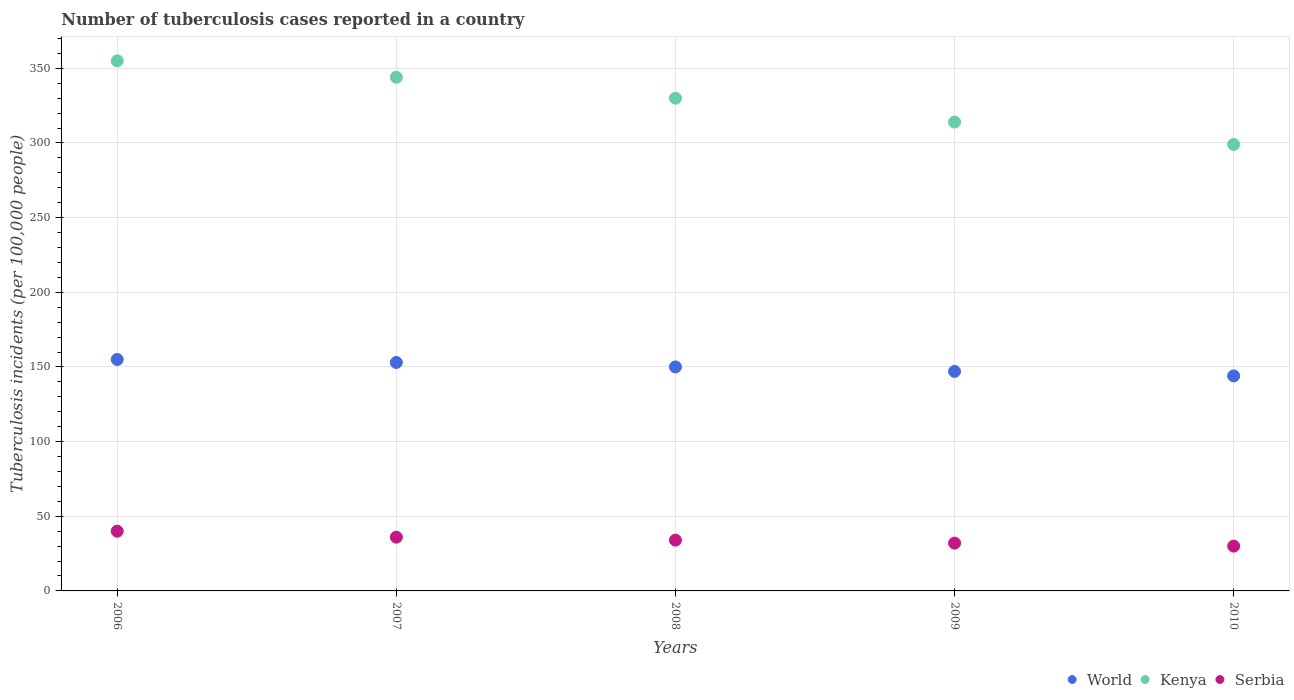How many different coloured dotlines are there?
Make the answer very short. 3. Is the number of dotlines equal to the number of legend labels?
Ensure brevity in your answer.  Yes. What is the number of tuberculosis cases reported in in World in 2008?
Your response must be concise. 150. Across all years, what is the maximum number of tuberculosis cases reported in in Serbia?
Offer a terse response. 40. Across all years, what is the minimum number of tuberculosis cases reported in in Serbia?
Your response must be concise. 30. In which year was the number of tuberculosis cases reported in in Kenya maximum?
Give a very brief answer. 2006. What is the total number of tuberculosis cases reported in in World in the graph?
Provide a short and direct response. 749. What is the difference between the number of tuberculosis cases reported in in Kenya in 2006 and that in 2007?
Provide a succinct answer. 11. What is the difference between the number of tuberculosis cases reported in in Kenya in 2010 and the number of tuberculosis cases reported in in Serbia in 2009?
Offer a terse response. 267. What is the average number of tuberculosis cases reported in in Kenya per year?
Provide a succinct answer. 328.4. In the year 2007, what is the difference between the number of tuberculosis cases reported in in Serbia and number of tuberculosis cases reported in in World?
Ensure brevity in your answer.  -117. What is the ratio of the number of tuberculosis cases reported in in World in 2008 to that in 2009?
Offer a very short reply. 1.02. Is the difference between the number of tuberculosis cases reported in in Serbia in 2006 and 2009 greater than the difference between the number of tuberculosis cases reported in in World in 2006 and 2009?
Offer a very short reply. No. What is the difference between the highest and the lowest number of tuberculosis cases reported in in World?
Keep it short and to the point. 11. How many dotlines are there?
Make the answer very short. 3. How many years are there in the graph?
Your answer should be compact. 5. Are the values on the major ticks of Y-axis written in scientific E-notation?
Ensure brevity in your answer.  No. Does the graph contain any zero values?
Keep it short and to the point. No. Does the graph contain grids?
Ensure brevity in your answer.  Yes. Where does the legend appear in the graph?
Provide a succinct answer. Bottom right. How many legend labels are there?
Ensure brevity in your answer.  3. How are the legend labels stacked?
Offer a very short reply. Horizontal. What is the title of the graph?
Your answer should be compact. Number of tuberculosis cases reported in a country. What is the label or title of the X-axis?
Offer a very short reply. Years. What is the label or title of the Y-axis?
Your answer should be very brief. Tuberculosis incidents (per 100,0 people). What is the Tuberculosis incidents (per 100,000 people) of World in 2006?
Keep it short and to the point. 155. What is the Tuberculosis incidents (per 100,000 people) of Kenya in 2006?
Offer a terse response. 355. What is the Tuberculosis incidents (per 100,000 people) of Serbia in 2006?
Provide a succinct answer. 40. What is the Tuberculosis incidents (per 100,000 people) in World in 2007?
Offer a terse response. 153. What is the Tuberculosis incidents (per 100,000 people) in Kenya in 2007?
Provide a short and direct response. 344. What is the Tuberculosis incidents (per 100,000 people) of World in 2008?
Your answer should be compact. 150. What is the Tuberculosis incidents (per 100,000 people) in Kenya in 2008?
Your response must be concise. 330. What is the Tuberculosis incidents (per 100,000 people) in Serbia in 2008?
Offer a very short reply. 34. What is the Tuberculosis incidents (per 100,000 people) of World in 2009?
Make the answer very short. 147. What is the Tuberculosis incidents (per 100,000 people) in Kenya in 2009?
Your answer should be compact. 314. What is the Tuberculosis incidents (per 100,000 people) in Serbia in 2009?
Provide a succinct answer. 32. What is the Tuberculosis incidents (per 100,000 people) in World in 2010?
Your response must be concise. 144. What is the Tuberculosis incidents (per 100,000 people) in Kenya in 2010?
Ensure brevity in your answer.  299. What is the Tuberculosis incidents (per 100,000 people) in Serbia in 2010?
Give a very brief answer. 30. Across all years, what is the maximum Tuberculosis incidents (per 100,000 people) of World?
Offer a terse response. 155. Across all years, what is the maximum Tuberculosis incidents (per 100,000 people) of Kenya?
Your answer should be very brief. 355. Across all years, what is the minimum Tuberculosis incidents (per 100,000 people) of World?
Keep it short and to the point. 144. Across all years, what is the minimum Tuberculosis incidents (per 100,000 people) in Kenya?
Your answer should be very brief. 299. What is the total Tuberculosis incidents (per 100,000 people) of World in the graph?
Your response must be concise. 749. What is the total Tuberculosis incidents (per 100,000 people) of Kenya in the graph?
Give a very brief answer. 1642. What is the total Tuberculosis incidents (per 100,000 people) of Serbia in the graph?
Offer a very short reply. 172. What is the difference between the Tuberculosis incidents (per 100,000 people) of Serbia in 2006 and that in 2007?
Make the answer very short. 4. What is the difference between the Tuberculosis incidents (per 100,000 people) in World in 2006 and that in 2008?
Give a very brief answer. 5. What is the difference between the Tuberculosis incidents (per 100,000 people) in Serbia in 2006 and that in 2008?
Provide a short and direct response. 6. What is the difference between the Tuberculosis incidents (per 100,000 people) in World in 2006 and that in 2009?
Ensure brevity in your answer.  8. What is the difference between the Tuberculosis incidents (per 100,000 people) of Serbia in 2006 and that in 2009?
Your answer should be very brief. 8. What is the difference between the Tuberculosis incidents (per 100,000 people) in Kenya in 2006 and that in 2010?
Ensure brevity in your answer.  56. What is the difference between the Tuberculosis incidents (per 100,000 people) in Serbia in 2006 and that in 2010?
Give a very brief answer. 10. What is the difference between the Tuberculosis incidents (per 100,000 people) in Serbia in 2007 and that in 2008?
Offer a very short reply. 2. What is the difference between the Tuberculosis incidents (per 100,000 people) in World in 2007 and that in 2009?
Your answer should be compact. 6. What is the difference between the Tuberculosis incidents (per 100,000 people) of Serbia in 2007 and that in 2009?
Give a very brief answer. 4. What is the difference between the Tuberculosis incidents (per 100,000 people) in Kenya in 2007 and that in 2010?
Your response must be concise. 45. What is the difference between the Tuberculosis incidents (per 100,000 people) of Kenya in 2008 and that in 2010?
Your answer should be compact. 31. What is the difference between the Tuberculosis incidents (per 100,000 people) in Serbia in 2008 and that in 2010?
Provide a succinct answer. 4. What is the difference between the Tuberculosis incidents (per 100,000 people) of World in 2009 and that in 2010?
Give a very brief answer. 3. What is the difference between the Tuberculosis incidents (per 100,000 people) in Kenya in 2009 and that in 2010?
Ensure brevity in your answer.  15. What is the difference between the Tuberculosis incidents (per 100,000 people) in World in 2006 and the Tuberculosis incidents (per 100,000 people) in Kenya in 2007?
Give a very brief answer. -189. What is the difference between the Tuberculosis incidents (per 100,000 people) in World in 2006 and the Tuberculosis incidents (per 100,000 people) in Serbia in 2007?
Your response must be concise. 119. What is the difference between the Tuberculosis incidents (per 100,000 people) of Kenya in 2006 and the Tuberculosis incidents (per 100,000 people) of Serbia in 2007?
Make the answer very short. 319. What is the difference between the Tuberculosis incidents (per 100,000 people) in World in 2006 and the Tuberculosis incidents (per 100,000 people) in Kenya in 2008?
Offer a terse response. -175. What is the difference between the Tuberculosis incidents (per 100,000 people) of World in 2006 and the Tuberculosis incidents (per 100,000 people) of Serbia in 2008?
Your answer should be compact. 121. What is the difference between the Tuberculosis incidents (per 100,000 people) of Kenya in 2006 and the Tuberculosis incidents (per 100,000 people) of Serbia in 2008?
Keep it short and to the point. 321. What is the difference between the Tuberculosis incidents (per 100,000 people) of World in 2006 and the Tuberculosis incidents (per 100,000 people) of Kenya in 2009?
Provide a short and direct response. -159. What is the difference between the Tuberculosis incidents (per 100,000 people) of World in 2006 and the Tuberculosis incidents (per 100,000 people) of Serbia in 2009?
Your answer should be compact. 123. What is the difference between the Tuberculosis incidents (per 100,000 people) in Kenya in 2006 and the Tuberculosis incidents (per 100,000 people) in Serbia in 2009?
Make the answer very short. 323. What is the difference between the Tuberculosis incidents (per 100,000 people) in World in 2006 and the Tuberculosis incidents (per 100,000 people) in Kenya in 2010?
Provide a succinct answer. -144. What is the difference between the Tuberculosis incidents (per 100,000 people) of World in 2006 and the Tuberculosis incidents (per 100,000 people) of Serbia in 2010?
Your answer should be compact. 125. What is the difference between the Tuberculosis incidents (per 100,000 people) in Kenya in 2006 and the Tuberculosis incidents (per 100,000 people) in Serbia in 2010?
Your answer should be compact. 325. What is the difference between the Tuberculosis incidents (per 100,000 people) of World in 2007 and the Tuberculosis incidents (per 100,000 people) of Kenya in 2008?
Your answer should be very brief. -177. What is the difference between the Tuberculosis incidents (per 100,000 people) of World in 2007 and the Tuberculosis incidents (per 100,000 people) of Serbia in 2008?
Your response must be concise. 119. What is the difference between the Tuberculosis incidents (per 100,000 people) of Kenya in 2007 and the Tuberculosis incidents (per 100,000 people) of Serbia in 2008?
Provide a short and direct response. 310. What is the difference between the Tuberculosis incidents (per 100,000 people) of World in 2007 and the Tuberculosis incidents (per 100,000 people) of Kenya in 2009?
Give a very brief answer. -161. What is the difference between the Tuberculosis incidents (per 100,000 people) of World in 2007 and the Tuberculosis incidents (per 100,000 people) of Serbia in 2009?
Your answer should be very brief. 121. What is the difference between the Tuberculosis incidents (per 100,000 people) in Kenya in 2007 and the Tuberculosis incidents (per 100,000 people) in Serbia in 2009?
Your answer should be compact. 312. What is the difference between the Tuberculosis incidents (per 100,000 people) of World in 2007 and the Tuberculosis incidents (per 100,000 people) of Kenya in 2010?
Provide a short and direct response. -146. What is the difference between the Tuberculosis incidents (per 100,000 people) of World in 2007 and the Tuberculosis incidents (per 100,000 people) of Serbia in 2010?
Ensure brevity in your answer.  123. What is the difference between the Tuberculosis incidents (per 100,000 people) of Kenya in 2007 and the Tuberculosis incidents (per 100,000 people) of Serbia in 2010?
Offer a very short reply. 314. What is the difference between the Tuberculosis incidents (per 100,000 people) in World in 2008 and the Tuberculosis incidents (per 100,000 people) in Kenya in 2009?
Make the answer very short. -164. What is the difference between the Tuberculosis incidents (per 100,000 people) in World in 2008 and the Tuberculosis incidents (per 100,000 people) in Serbia in 2009?
Your answer should be compact. 118. What is the difference between the Tuberculosis incidents (per 100,000 people) of Kenya in 2008 and the Tuberculosis incidents (per 100,000 people) of Serbia in 2009?
Provide a succinct answer. 298. What is the difference between the Tuberculosis incidents (per 100,000 people) in World in 2008 and the Tuberculosis incidents (per 100,000 people) in Kenya in 2010?
Provide a short and direct response. -149. What is the difference between the Tuberculosis incidents (per 100,000 people) of World in 2008 and the Tuberculosis incidents (per 100,000 people) of Serbia in 2010?
Provide a short and direct response. 120. What is the difference between the Tuberculosis incidents (per 100,000 people) of Kenya in 2008 and the Tuberculosis incidents (per 100,000 people) of Serbia in 2010?
Your answer should be very brief. 300. What is the difference between the Tuberculosis incidents (per 100,000 people) of World in 2009 and the Tuberculosis incidents (per 100,000 people) of Kenya in 2010?
Your answer should be very brief. -152. What is the difference between the Tuberculosis incidents (per 100,000 people) of World in 2009 and the Tuberculosis incidents (per 100,000 people) of Serbia in 2010?
Ensure brevity in your answer.  117. What is the difference between the Tuberculosis incidents (per 100,000 people) in Kenya in 2009 and the Tuberculosis incidents (per 100,000 people) in Serbia in 2010?
Your answer should be very brief. 284. What is the average Tuberculosis incidents (per 100,000 people) of World per year?
Offer a terse response. 149.8. What is the average Tuberculosis incidents (per 100,000 people) of Kenya per year?
Make the answer very short. 328.4. What is the average Tuberculosis incidents (per 100,000 people) of Serbia per year?
Offer a terse response. 34.4. In the year 2006, what is the difference between the Tuberculosis incidents (per 100,000 people) of World and Tuberculosis incidents (per 100,000 people) of Kenya?
Ensure brevity in your answer.  -200. In the year 2006, what is the difference between the Tuberculosis incidents (per 100,000 people) of World and Tuberculosis incidents (per 100,000 people) of Serbia?
Keep it short and to the point. 115. In the year 2006, what is the difference between the Tuberculosis incidents (per 100,000 people) in Kenya and Tuberculosis incidents (per 100,000 people) in Serbia?
Give a very brief answer. 315. In the year 2007, what is the difference between the Tuberculosis incidents (per 100,000 people) in World and Tuberculosis incidents (per 100,000 people) in Kenya?
Provide a succinct answer. -191. In the year 2007, what is the difference between the Tuberculosis incidents (per 100,000 people) of World and Tuberculosis incidents (per 100,000 people) of Serbia?
Ensure brevity in your answer.  117. In the year 2007, what is the difference between the Tuberculosis incidents (per 100,000 people) of Kenya and Tuberculosis incidents (per 100,000 people) of Serbia?
Offer a terse response. 308. In the year 2008, what is the difference between the Tuberculosis incidents (per 100,000 people) of World and Tuberculosis incidents (per 100,000 people) of Kenya?
Offer a terse response. -180. In the year 2008, what is the difference between the Tuberculosis incidents (per 100,000 people) of World and Tuberculosis incidents (per 100,000 people) of Serbia?
Provide a succinct answer. 116. In the year 2008, what is the difference between the Tuberculosis incidents (per 100,000 people) in Kenya and Tuberculosis incidents (per 100,000 people) in Serbia?
Make the answer very short. 296. In the year 2009, what is the difference between the Tuberculosis incidents (per 100,000 people) in World and Tuberculosis incidents (per 100,000 people) in Kenya?
Your answer should be very brief. -167. In the year 2009, what is the difference between the Tuberculosis incidents (per 100,000 people) of World and Tuberculosis incidents (per 100,000 people) of Serbia?
Offer a very short reply. 115. In the year 2009, what is the difference between the Tuberculosis incidents (per 100,000 people) in Kenya and Tuberculosis incidents (per 100,000 people) in Serbia?
Ensure brevity in your answer.  282. In the year 2010, what is the difference between the Tuberculosis incidents (per 100,000 people) in World and Tuberculosis incidents (per 100,000 people) in Kenya?
Ensure brevity in your answer.  -155. In the year 2010, what is the difference between the Tuberculosis incidents (per 100,000 people) in World and Tuberculosis incidents (per 100,000 people) in Serbia?
Provide a short and direct response. 114. In the year 2010, what is the difference between the Tuberculosis incidents (per 100,000 people) of Kenya and Tuberculosis incidents (per 100,000 people) of Serbia?
Provide a short and direct response. 269. What is the ratio of the Tuberculosis incidents (per 100,000 people) of World in 2006 to that in 2007?
Your answer should be compact. 1.01. What is the ratio of the Tuberculosis incidents (per 100,000 people) in Kenya in 2006 to that in 2007?
Give a very brief answer. 1.03. What is the ratio of the Tuberculosis incidents (per 100,000 people) of Kenya in 2006 to that in 2008?
Give a very brief answer. 1.08. What is the ratio of the Tuberculosis incidents (per 100,000 people) in Serbia in 2006 to that in 2008?
Ensure brevity in your answer.  1.18. What is the ratio of the Tuberculosis incidents (per 100,000 people) in World in 2006 to that in 2009?
Offer a very short reply. 1.05. What is the ratio of the Tuberculosis incidents (per 100,000 people) of Kenya in 2006 to that in 2009?
Offer a very short reply. 1.13. What is the ratio of the Tuberculosis incidents (per 100,000 people) in Serbia in 2006 to that in 2009?
Your answer should be very brief. 1.25. What is the ratio of the Tuberculosis incidents (per 100,000 people) in World in 2006 to that in 2010?
Provide a succinct answer. 1.08. What is the ratio of the Tuberculosis incidents (per 100,000 people) of Kenya in 2006 to that in 2010?
Provide a short and direct response. 1.19. What is the ratio of the Tuberculosis incidents (per 100,000 people) of World in 2007 to that in 2008?
Your answer should be very brief. 1.02. What is the ratio of the Tuberculosis incidents (per 100,000 people) in Kenya in 2007 to that in 2008?
Your answer should be very brief. 1.04. What is the ratio of the Tuberculosis incidents (per 100,000 people) in Serbia in 2007 to that in 2008?
Offer a very short reply. 1.06. What is the ratio of the Tuberculosis incidents (per 100,000 people) of World in 2007 to that in 2009?
Give a very brief answer. 1.04. What is the ratio of the Tuberculosis incidents (per 100,000 people) in Kenya in 2007 to that in 2009?
Ensure brevity in your answer.  1.1. What is the ratio of the Tuberculosis incidents (per 100,000 people) in Kenya in 2007 to that in 2010?
Make the answer very short. 1.15. What is the ratio of the Tuberculosis incidents (per 100,000 people) of World in 2008 to that in 2009?
Offer a very short reply. 1.02. What is the ratio of the Tuberculosis incidents (per 100,000 people) of Kenya in 2008 to that in 2009?
Offer a terse response. 1.05. What is the ratio of the Tuberculosis incidents (per 100,000 people) in World in 2008 to that in 2010?
Make the answer very short. 1.04. What is the ratio of the Tuberculosis incidents (per 100,000 people) of Kenya in 2008 to that in 2010?
Your answer should be very brief. 1.1. What is the ratio of the Tuberculosis incidents (per 100,000 people) in Serbia in 2008 to that in 2010?
Provide a short and direct response. 1.13. What is the ratio of the Tuberculosis incidents (per 100,000 people) in World in 2009 to that in 2010?
Offer a very short reply. 1.02. What is the ratio of the Tuberculosis incidents (per 100,000 people) in Kenya in 2009 to that in 2010?
Your response must be concise. 1.05. What is the ratio of the Tuberculosis incidents (per 100,000 people) in Serbia in 2009 to that in 2010?
Provide a succinct answer. 1.07. What is the difference between the highest and the second highest Tuberculosis incidents (per 100,000 people) in World?
Offer a terse response. 2. What is the difference between the highest and the second highest Tuberculosis incidents (per 100,000 people) in Kenya?
Provide a short and direct response. 11. 